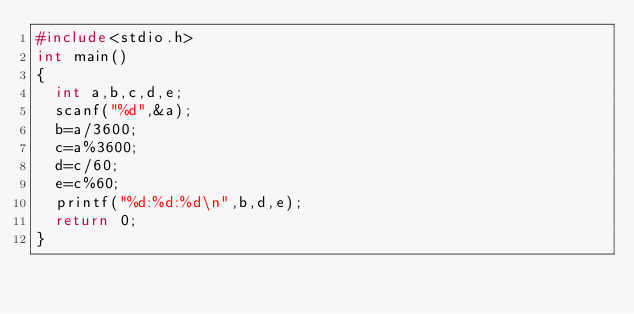Convert code to text. <code><loc_0><loc_0><loc_500><loc_500><_C_>#include<stdio.h>
int main()
{
  int a,b,c,d,e;
  scanf("%d",&a);
  b=a/3600;
  c=a%3600;
  d=c/60;
  e=c%60;
  printf("%d:%d:%d\n",b,d,e);
  return 0;
}


</code> 